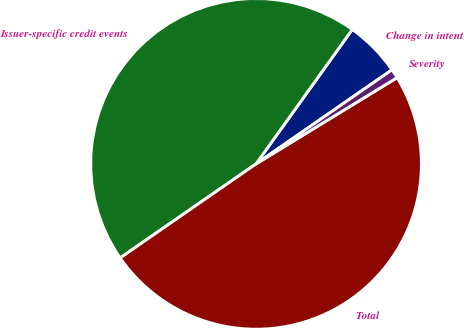<chart> <loc_0><loc_0><loc_500><loc_500><pie_chart><fcel>Change in intent<fcel>Issuer-specific credit events<fcel>Total<fcel>Severity<nl><fcel>5.48%<fcel>44.52%<fcel>49.1%<fcel>0.9%<nl></chart> 